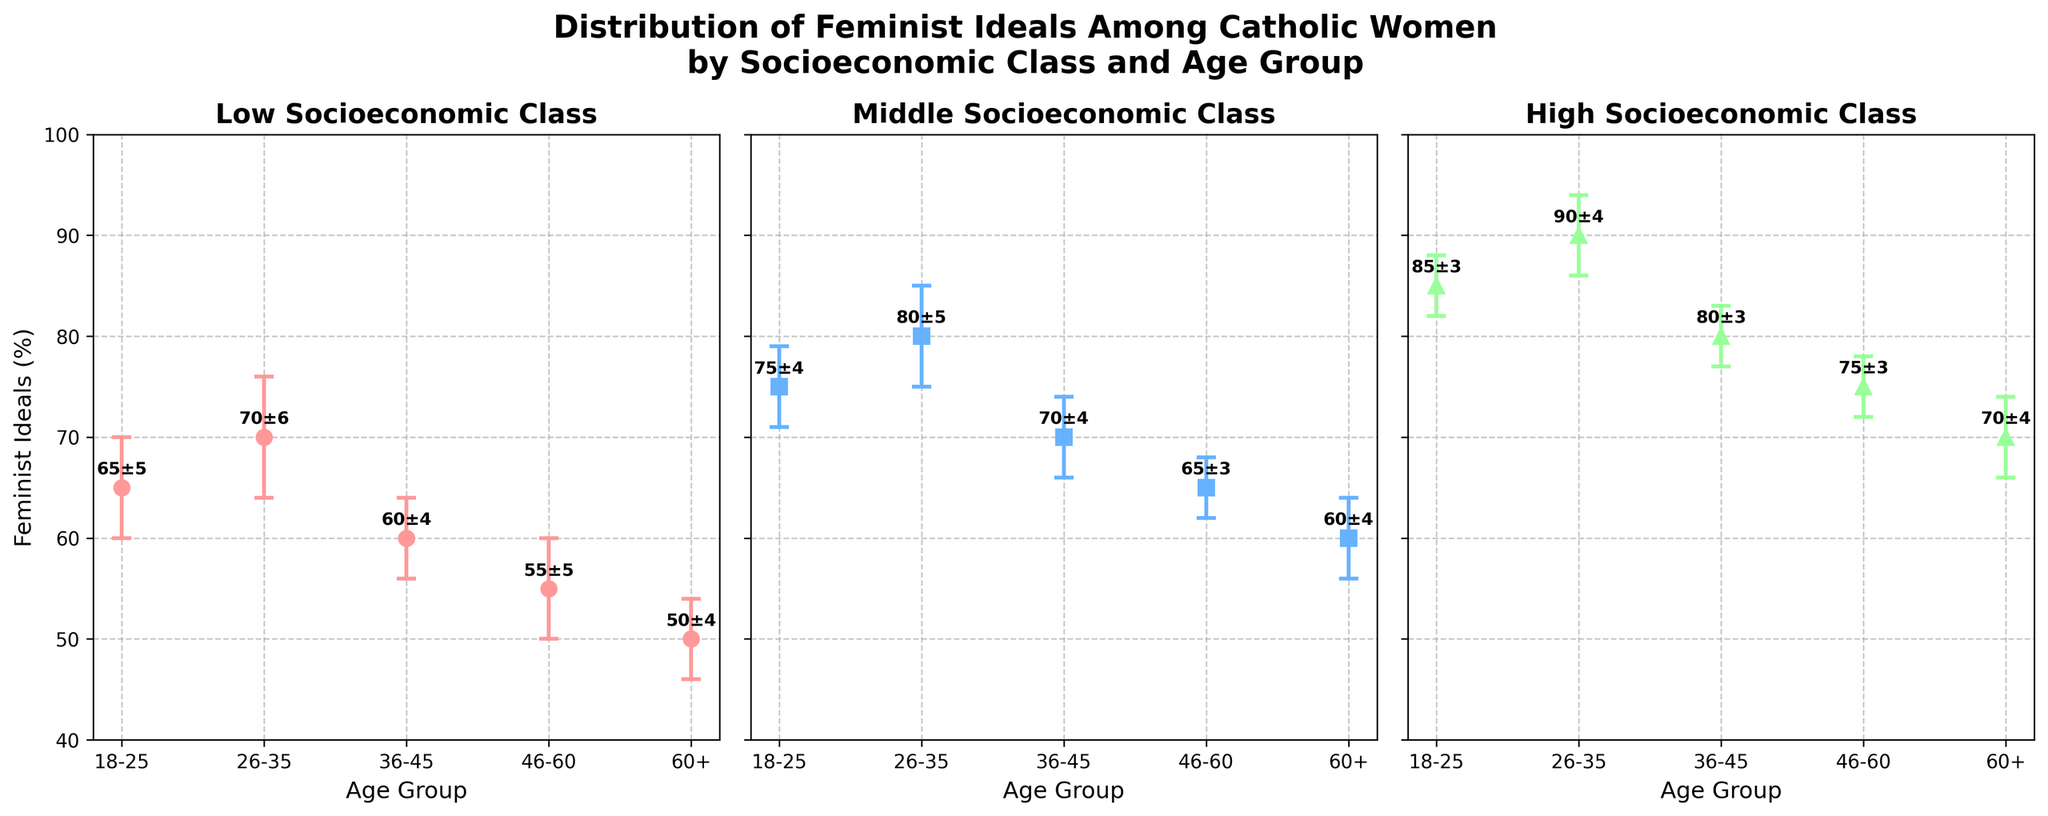How many age groups are represented in the figure? There are five age groups listed along the x-axis for each subplot: 18-25, 26-35, 36-45, 46-60, and 60+.
Answer: Five What is the highest value of feminist ideals reported among the high socioeconomic class? The highest value reported among the high socioeconomic class is found at the age group 26-35, which is 90%.
Answer: 90% Which age group has the lowest feminist ideals in the low socioeconomic class? The lowest feminist ideals in the low socioeconomic class are observed in the 60+ age group, which is indicated as 50%.
Answer: 60+ How do the feminist ideals of the 36-45 age group compare between the low, middle, and high socioeconomic classes? The feminist ideals for the 36-45 age group are 60% (Low), 70% (Middle), and 80% (High). Therefore, the feminist ideals increase as the socioeconomic class increases for this age group.
Answer: Low < Middle < High What is the difference in feminist ideals between the 18-25 and 60+ age groups in the middle socioeconomic class? The feminist ideals for the 18-25 age group are 75% and for the 60+ age group are 60% in the middle socioeconomic class. The difference is 75 - 60 = 15%.
Answer: 15% Which socioeconomic class shows the smallest variation in feminist ideals across all age groups? By looking at the error bars, the middle socioeconomic class shows the smallest variation in feminist ideals across all age groups, with closely spaced error bars.
Answer: Middle What is the average value of feminist ideals for the age group 26-35 across all socioeconomic classes? The values for the 26-35 age group are 70% (Low), 80% (Middle), and 90% (High). The average is (70 + 80 + 90) / 3 = 80%.
Answer: 80% Does the figure show any age group with overlapping error bars among different socioeconomic classes, indicating similar levels of feminist ideals? Yes, the 60+ age group shows overlapping error bars between the low and middle socioeconomic classes, indicating similar levels of feminist ideals.
Answer: Yes How does the feminist ideal of the 46-60 age group in the high socioeconomic class compare to the same age group in the low and middle socioeconomic classes? The feminist ideals for the 46-60 age group are 55% (Low), 65% (Middle), and 75% (High). Therefore, the high socioeconomic class has the highest value compared to the low and middle classes.
Answer: High > Middle > Low 